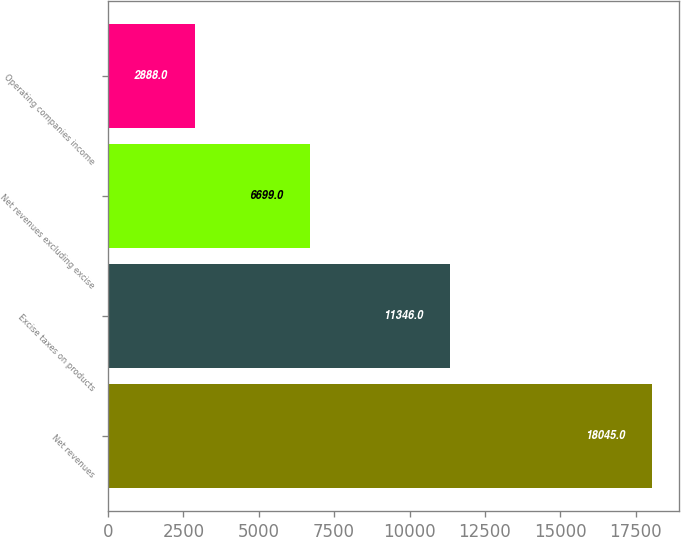Convert chart to OTSL. <chart><loc_0><loc_0><loc_500><loc_500><bar_chart><fcel>Net revenues<fcel>Excise taxes on products<fcel>Net revenues excluding excise<fcel>Operating companies income<nl><fcel>18045<fcel>11346<fcel>6699<fcel>2888<nl></chart> 